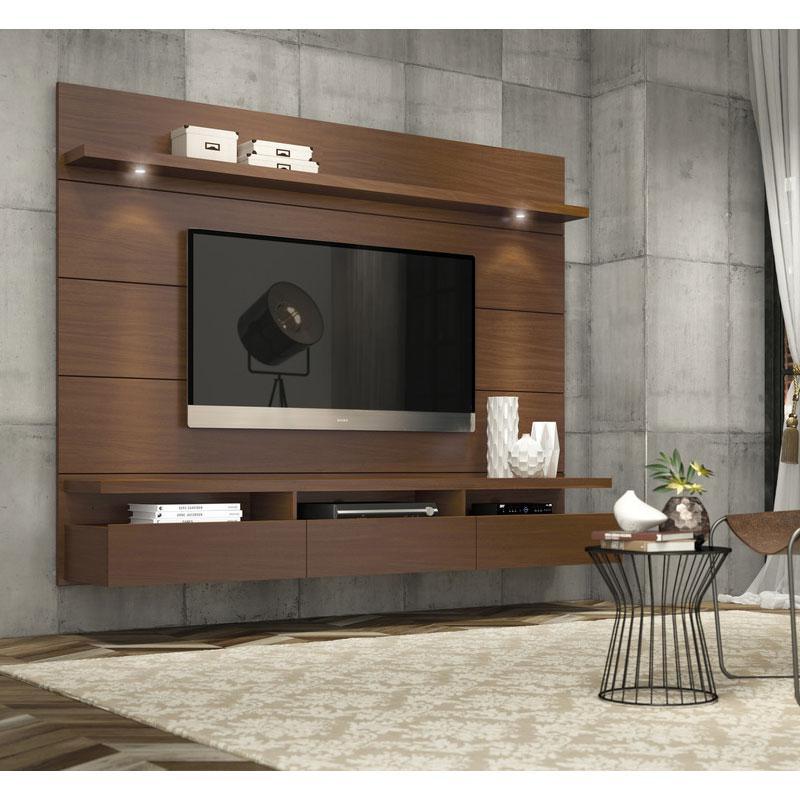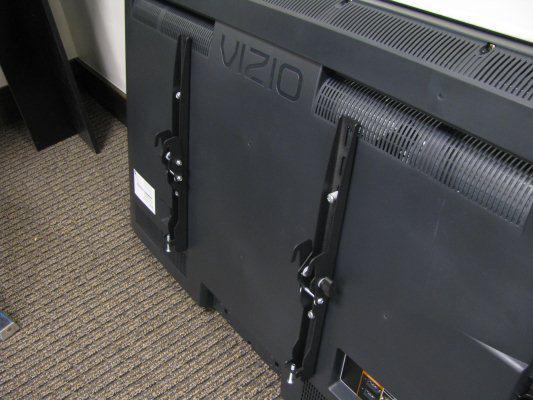The first image is the image on the left, the second image is the image on the right. For the images shown, is this caption "In the left image a television is attached to the wall." true? Answer yes or no. Yes. The first image is the image on the left, the second image is the image on the right. Examine the images to the left and right. Is the description "The right image shows a side-view of a TV on a pivoting wall-mounted arm, and the left image shows a TV screen above a narrow shelf." accurate? Answer yes or no. No. 